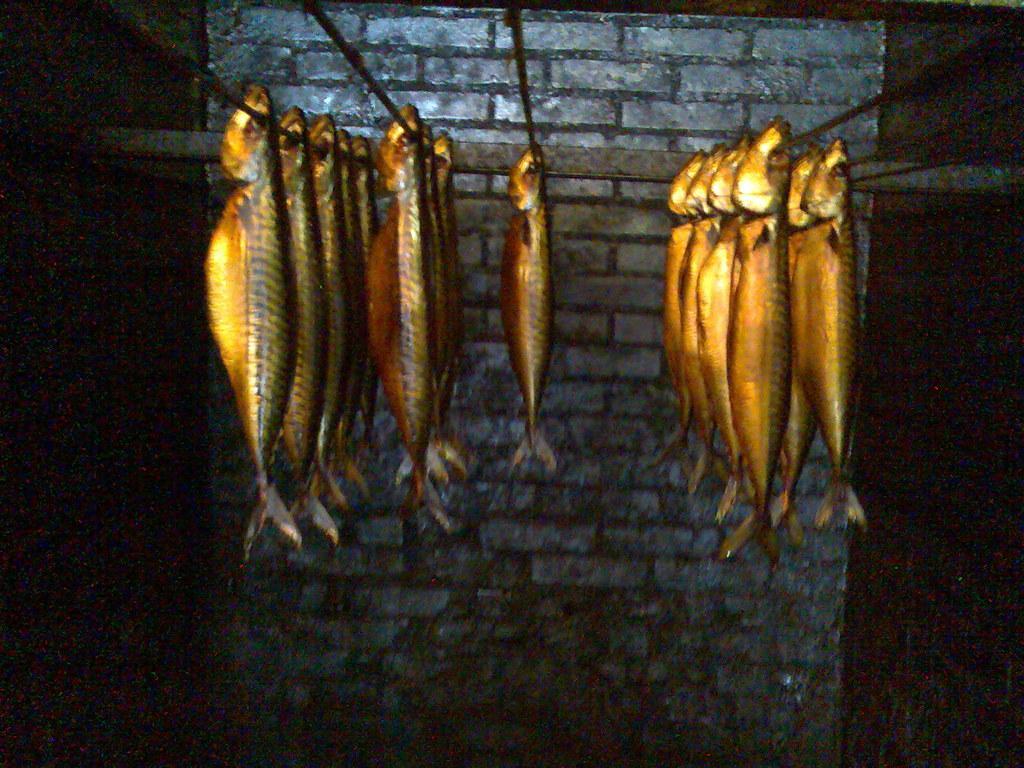Can you describe this image briefly? In the center of the image we can see a fishes and rods are present. In the background of the image a wall is there. 